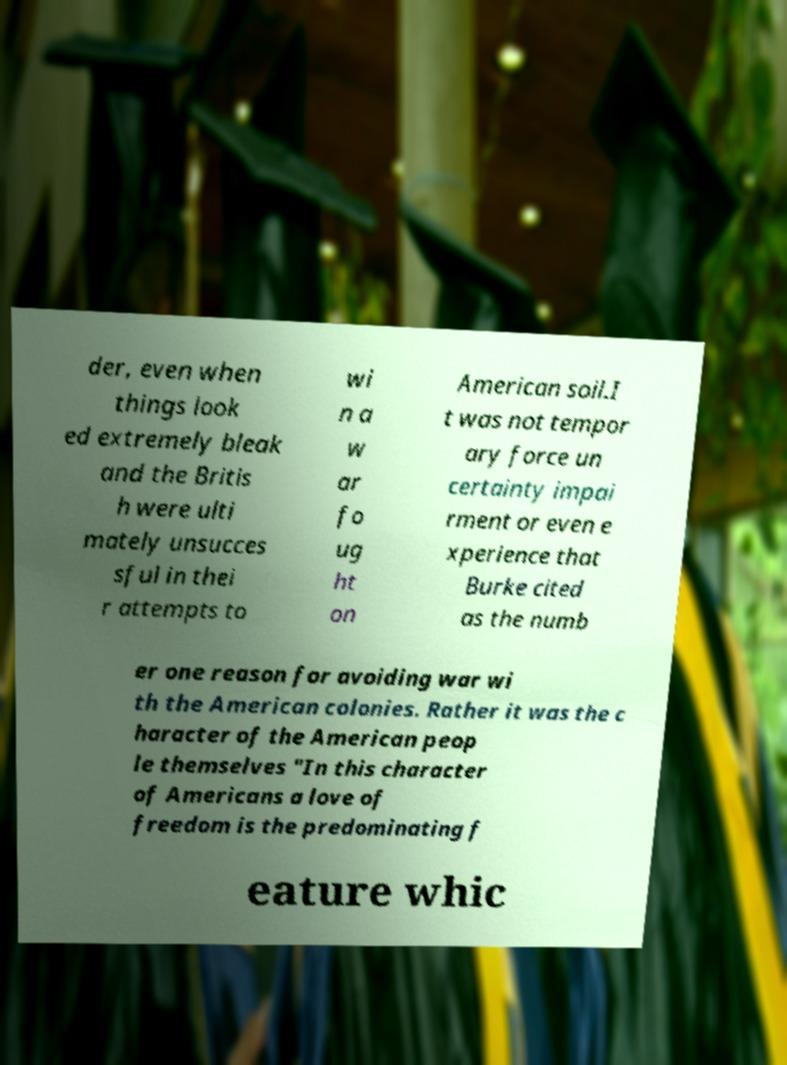For documentation purposes, I need the text within this image transcribed. Could you provide that? der, even when things look ed extremely bleak and the Britis h were ulti mately unsucces sful in thei r attempts to wi n a w ar fo ug ht on American soil.I t was not tempor ary force un certainty impai rment or even e xperience that Burke cited as the numb er one reason for avoiding war wi th the American colonies. Rather it was the c haracter of the American peop le themselves "In this character of Americans a love of freedom is the predominating f eature whic 